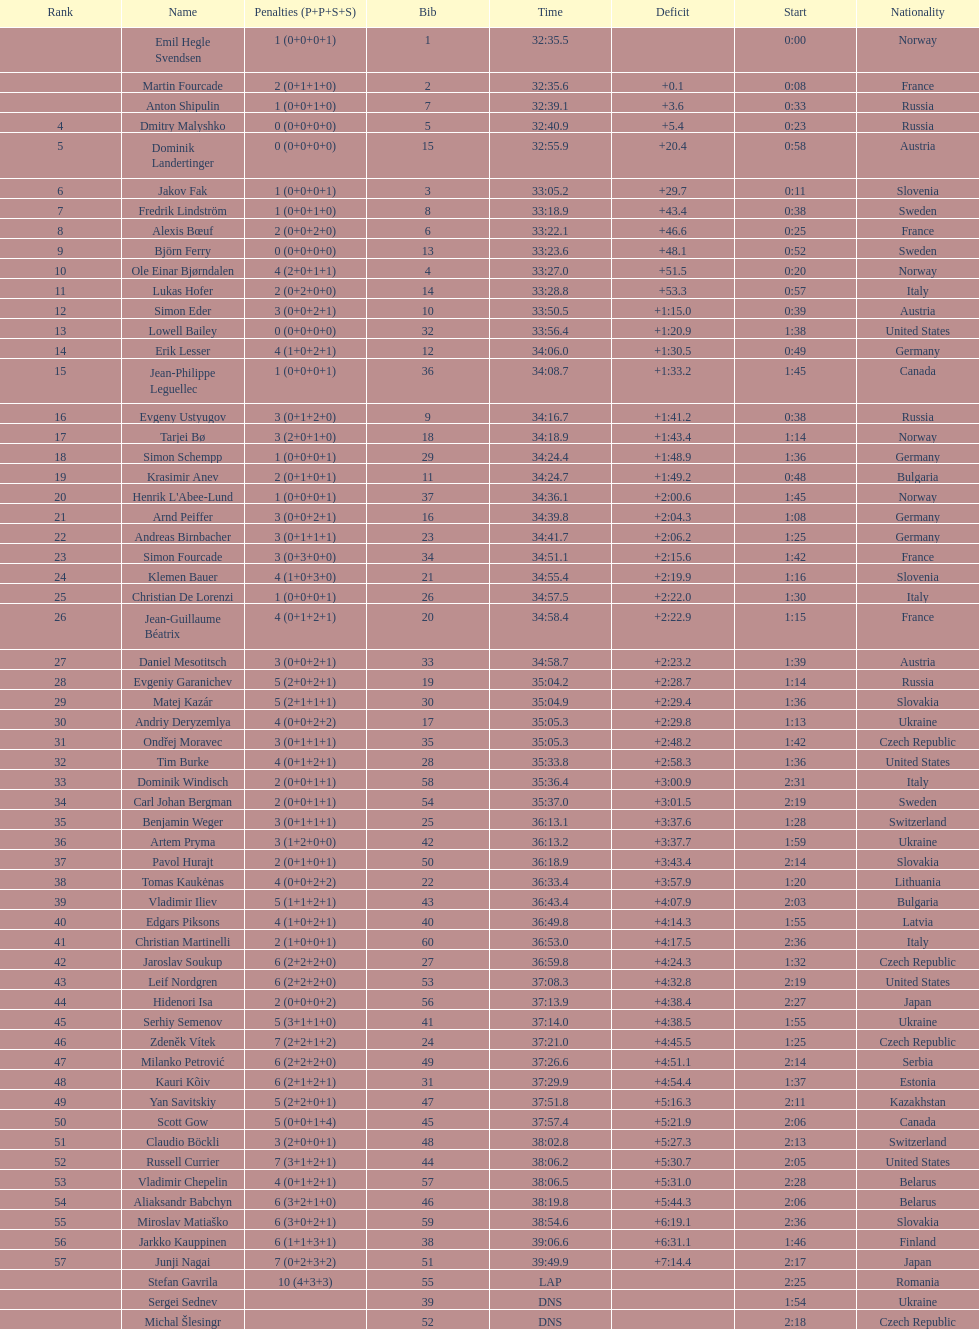What is the quantity of russian participants? 4. 